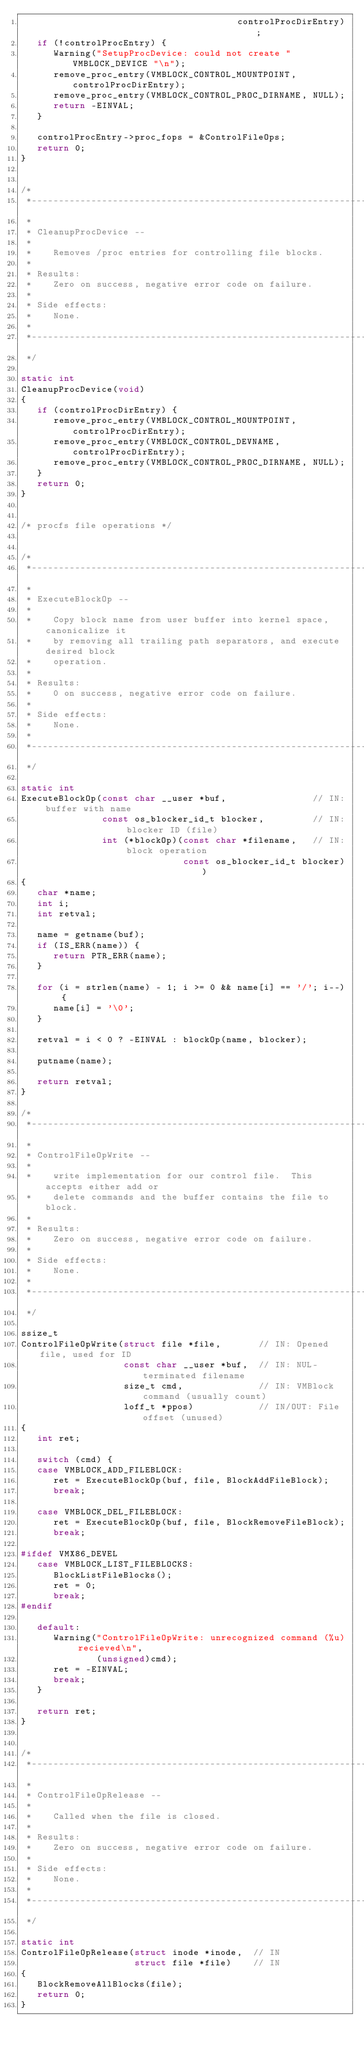<code> <loc_0><loc_0><loc_500><loc_500><_C_>                                        controlProcDirEntry);
   if (!controlProcEntry) {
      Warning("SetupProcDevice: could not create " VMBLOCK_DEVICE "\n");
      remove_proc_entry(VMBLOCK_CONTROL_MOUNTPOINT, controlProcDirEntry);
      remove_proc_entry(VMBLOCK_CONTROL_PROC_DIRNAME, NULL);
      return -EINVAL;
   }

   controlProcEntry->proc_fops = &ControlFileOps;
   return 0;
}


/*
 *----------------------------------------------------------------------------
 *
 * CleanupProcDevice --
 *
 *    Removes /proc entries for controlling file blocks.
 *
 * Results:
 *    Zero on success, negative error code on failure.
 *
 * Side effects:
 *    None.
 *
 *----------------------------------------------------------------------------
 */

static int
CleanupProcDevice(void)
{
   if (controlProcDirEntry) {
      remove_proc_entry(VMBLOCK_CONTROL_MOUNTPOINT, controlProcDirEntry);
      remove_proc_entry(VMBLOCK_CONTROL_DEVNAME, controlProcDirEntry);
      remove_proc_entry(VMBLOCK_CONTROL_PROC_DIRNAME, NULL);
   }
   return 0;
}


/* procfs file operations */


/*
 *----------------------------------------------------------------------------
 *
 * ExecuteBlockOp --
 *
 *    Copy block name from user buffer into kernel space, canonicalize it
 *    by removing all trailing path separators, and execute desired block
 *    operation.
 *
 * Results:
 *    0 on success, negative error code on failure.
 *
 * Side effects:
 *    None.
 *
 *----------------------------------------------------------------------------
 */

static int
ExecuteBlockOp(const char __user *buf,                // IN: buffer with name
               const os_blocker_id_t blocker,         // IN: blocker ID (file)
               int (*blockOp)(const char *filename,   // IN: block operation
                              const os_blocker_id_t blocker))
{
   char *name;
   int i;
   int retval;

   name = getname(buf);
   if (IS_ERR(name)) {
      return PTR_ERR(name);
   }

   for (i = strlen(name) - 1; i >= 0 && name[i] == '/'; i--) {
      name[i] = '\0';
   }

   retval = i < 0 ? -EINVAL : blockOp(name, blocker);

   putname(name);

   return retval;
}

/*
 *----------------------------------------------------------------------------
 *
 * ControlFileOpWrite --
 *
 *    write implementation for our control file.  This accepts either add or
 *    delete commands and the buffer contains the file to block.
 *
 * Results:
 *    Zero on success, negative error code on failure.
 *
 * Side effects:
 *    None.
 *
 *----------------------------------------------------------------------------
 */

ssize_t
ControlFileOpWrite(struct file *file,       // IN: Opened file, used for ID
                   const char __user *buf,  // IN: NUL-terminated filename
                   size_t cmd,              // IN: VMBlock command (usually count)
                   loff_t *ppos)            // IN/OUT: File offset (unused)
{
   int ret;

   switch (cmd) {
   case VMBLOCK_ADD_FILEBLOCK:
      ret = ExecuteBlockOp(buf, file, BlockAddFileBlock);
      break;

   case VMBLOCK_DEL_FILEBLOCK:
      ret = ExecuteBlockOp(buf, file, BlockRemoveFileBlock);
      break;

#ifdef VMX86_DEVEL
   case VMBLOCK_LIST_FILEBLOCKS:
      BlockListFileBlocks();
      ret = 0;
      break;
#endif

   default:
      Warning("ControlFileOpWrite: unrecognized command (%u) recieved\n",
              (unsigned)cmd);
      ret = -EINVAL;
      break;
   }

   return ret;
}


/*
 *----------------------------------------------------------------------------
 *
 * ControlFileOpRelease --
 *
 *    Called when the file is closed.
 *
 * Results:
 *    Zero on success, negative error code on failure.
 *
 * Side effects:
 *    None.
 *
 *----------------------------------------------------------------------------
 */

static int
ControlFileOpRelease(struct inode *inode,  // IN
                     struct file *file)    // IN
{
   BlockRemoveAllBlocks(file);
   return 0;
}
</code> 